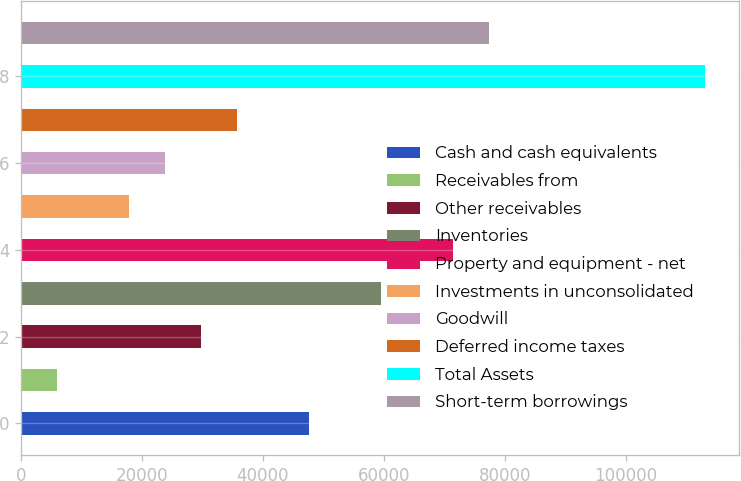Convert chart. <chart><loc_0><loc_0><loc_500><loc_500><bar_chart><fcel>Cash and cash equivalents<fcel>Receivables from<fcel>Other receivables<fcel>Inventories<fcel>Property and equipment - net<fcel>Investments in unconsolidated<fcel>Goodwill<fcel>Deferred income taxes<fcel>Total Assets<fcel>Short-term borrowings<nl><fcel>47617.4<fcel>5953.84<fcel>29761.6<fcel>59521.3<fcel>71425.2<fcel>17857.7<fcel>23809.7<fcel>35713.5<fcel>113089<fcel>77377.1<nl></chart> 